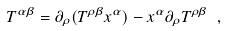Convert formula to latex. <formula><loc_0><loc_0><loc_500><loc_500>T ^ { \alpha \beta } = \partial _ { \rho } ( T ^ { \rho \beta } x ^ { \alpha } ) - x ^ { \alpha } \partial _ { \rho } T ^ { \rho \beta } \ ,</formula> 